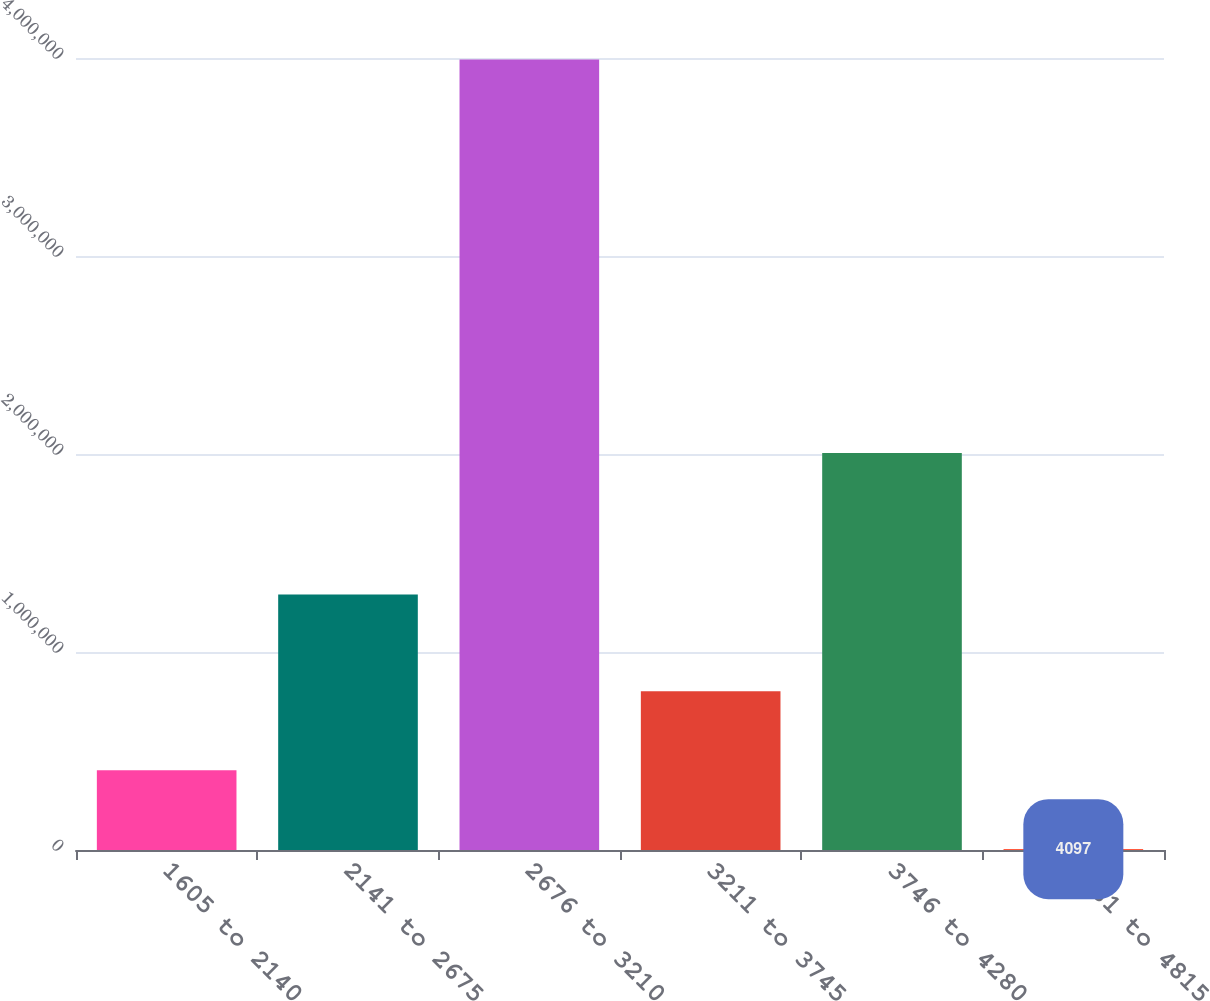<chart> <loc_0><loc_0><loc_500><loc_500><bar_chart><fcel>1605 to 2140<fcel>2141 to 2675<fcel>2676 to 3210<fcel>3211 to 3745<fcel>3746 to 4280<fcel>4281 to 4815<nl><fcel>402941<fcel>1.29039e+06<fcel>3.99253e+06<fcel>801784<fcel>2.00525e+06<fcel>4097<nl></chart> 